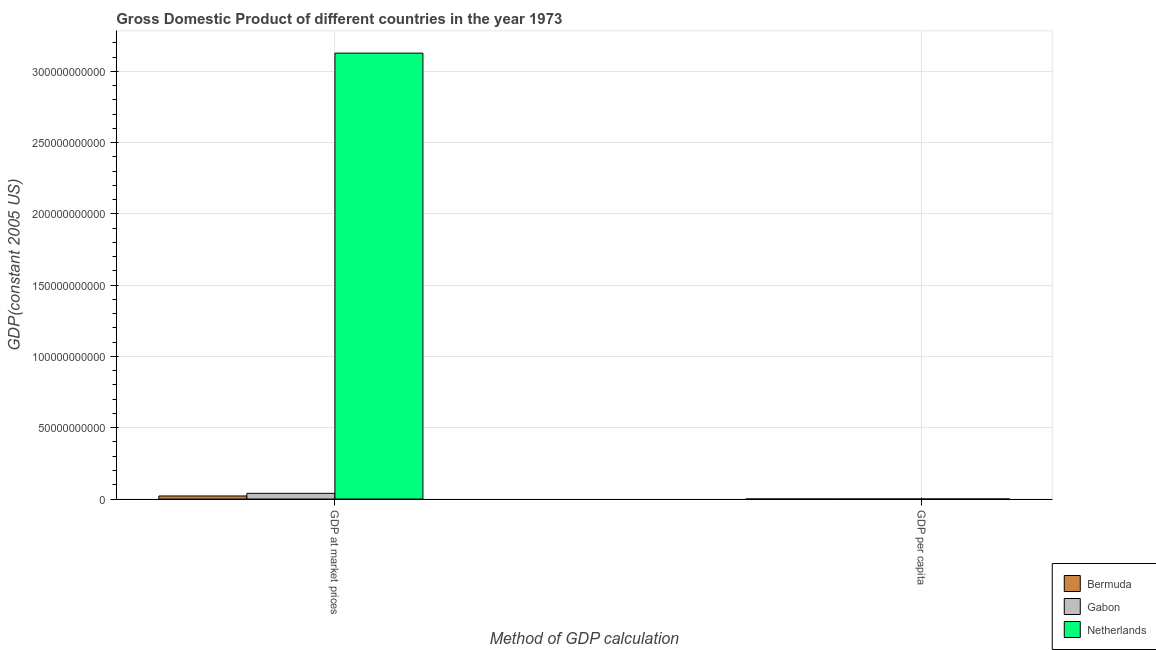How many different coloured bars are there?
Give a very brief answer. 3. Are the number of bars per tick equal to the number of legend labels?
Offer a very short reply. Yes. Are the number of bars on each tick of the X-axis equal?
Make the answer very short. Yes. How many bars are there on the 1st tick from the left?
Provide a short and direct response. 3. How many bars are there on the 1st tick from the right?
Offer a terse response. 3. What is the label of the 1st group of bars from the left?
Give a very brief answer. GDP at market prices. What is the gdp at market prices in Netherlands?
Give a very brief answer. 3.13e+11. Across all countries, what is the maximum gdp per capita?
Offer a terse response. 3.98e+04. Across all countries, what is the minimum gdp at market prices?
Keep it short and to the point. 2.14e+09. In which country was the gdp per capita minimum?
Ensure brevity in your answer.  Gabon. What is the total gdp at market prices in the graph?
Provide a succinct answer. 3.19e+11. What is the difference between the gdp at market prices in Bermuda and that in Gabon?
Offer a terse response. -1.85e+09. What is the difference between the gdp at market prices in Bermuda and the gdp per capita in Netherlands?
Keep it short and to the point. 2.14e+09. What is the average gdp per capita per country?
Give a very brief answer. 2.32e+04. What is the difference between the gdp per capita and gdp at market prices in Netherlands?
Your response must be concise. -3.13e+11. What is the ratio of the gdp at market prices in Bermuda to that in Netherlands?
Your answer should be compact. 0.01. In how many countries, is the gdp per capita greater than the average gdp per capita taken over all countries?
Offer a terse response. 2. What does the 1st bar from the left in GDP per capita represents?
Provide a succinct answer. Bermuda. What does the 2nd bar from the right in GDP per capita represents?
Your response must be concise. Gabon. How many bars are there?
Ensure brevity in your answer.  6. Are all the bars in the graph horizontal?
Your answer should be compact. No. Does the graph contain any zero values?
Keep it short and to the point. No. How are the legend labels stacked?
Provide a succinct answer. Vertical. What is the title of the graph?
Your answer should be very brief. Gross Domestic Product of different countries in the year 1973. What is the label or title of the X-axis?
Provide a succinct answer. Method of GDP calculation. What is the label or title of the Y-axis?
Provide a succinct answer. GDP(constant 2005 US). What is the GDP(constant 2005 US) in Bermuda in GDP at market prices?
Offer a very short reply. 2.14e+09. What is the GDP(constant 2005 US) in Gabon in GDP at market prices?
Offer a very short reply. 3.99e+09. What is the GDP(constant 2005 US) in Netherlands in GDP at market prices?
Your answer should be compact. 3.13e+11. What is the GDP(constant 2005 US) in Bermuda in GDP per capita?
Provide a short and direct response. 3.98e+04. What is the GDP(constant 2005 US) of Gabon in GDP per capita?
Offer a very short reply. 6388.75. What is the GDP(constant 2005 US) in Netherlands in GDP per capita?
Provide a short and direct response. 2.33e+04. Across all Method of GDP calculation, what is the maximum GDP(constant 2005 US) of Bermuda?
Provide a short and direct response. 2.14e+09. Across all Method of GDP calculation, what is the maximum GDP(constant 2005 US) in Gabon?
Offer a terse response. 3.99e+09. Across all Method of GDP calculation, what is the maximum GDP(constant 2005 US) in Netherlands?
Your answer should be compact. 3.13e+11. Across all Method of GDP calculation, what is the minimum GDP(constant 2005 US) of Bermuda?
Give a very brief answer. 3.98e+04. Across all Method of GDP calculation, what is the minimum GDP(constant 2005 US) in Gabon?
Make the answer very short. 6388.75. Across all Method of GDP calculation, what is the minimum GDP(constant 2005 US) in Netherlands?
Provide a short and direct response. 2.33e+04. What is the total GDP(constant 2005 US) of Bermuda in the graph?
Provide a succinct answer. 2.14e+09. What is the total GDP(constant 2005 US) of Gabon in the graph?
Offer a very short reply. 3.99e+09. What is the total GDP(constant 2005 US) in Netherlands in the graph?
Provide a short and direct response. 3.13e+11. What is the difference between the GDP(constant 2005 US) of Bermuda in GDP at market prices and that in GDP per capita?
Keep it short and to the point. 2.14e+09. What is the difference between the GDP(constant 2005 US) in Gabon in GDP at market prices and that in GDP per capita?
Ensure brevity in your answer.  3.99e+09. What is the difference between the GDP(constant 2005 US) of Netherlands in GDP at market prices and that in GDP per capita?
Provide a short and direct response. 3.13e+11. What is the difference between the GDP(constant 2005 US) of Bermuda in GDP at market prices and the GDP(constant 2005 US) of Gabon in GDP per capita?
Make the answer very short. 2.14e+09. What is the difference between the GDP(constant 2005 US) of Bermuda in GDP at market prices and the GDP(constant 2005 US) of Netherlands in GDP per capita?
Your answer should be compact. 2.14e+09. What is the difference between the GDP(constant 2005 US) of Gabon in GDP at market prices and the GDP(constant 2005 US) of Netherlands in GDP per capita?
Ensure brevity in your answer.  3.99e+09. What is the average GDP(constant 2005 US) in Bermuda per Method of GDP calculation?
Make the answer very short. 1.07e+09. What is the average GDP(constant 2005 US) of Gabon per Method of GDP calculation?
Offer a terse response. 2.00e+09. What is the average GDP(constant 2005 US) of Netherlands per Method of GDP calculation?
Provide a succinct answer. 1.56e+11. What is the difference between the GDP(constant 2005 US) in Bermuda and GDP(constant 2005 US) in Gabon in GDP at market prices?
Offer a very short reply. -1.85e+09. What is the difference between the GDP(constant 2005 US) in Bermuda and GDP(constant 2005 US) in Netherlands in GDP at market prices?
Give a very brief answer. -3.11e+11. What is the difference between the GDP(constant 2005 US) in Gabon and GDP(constant 2005 US) in Netherlands in GDP at market prices?
Give a very brief answer. -3.09e+11. What is the difference between the GDP(constant 2005 US) of Bermuda and GDP(constant 2005 US) of Gabon in GDP per capita?
Give a very brief answer. 3.34e+04. What is the difference between the GDP(constant 2005 US) of Bermuda and GDP(constant 2005 US) of Netherlands in GDP per capita?
Give a very brief answer. 1.65e+04. What is the difference between the GDP(constant 2005 US) in Gabon and GDP(constant 2005 US) in Netherlands in GDP per capita?
Make the answer very short. -1.69e+04. What is the ratio of the GDP(constant 2005 US) of Bermuda in GDP at market prices to that in GDP per capita?
Your answer should be very brief. 5.38e+04. What is the ratio of the GDP(constant 2005 US) of Gabon in GDP at market prices to that in GDP per capita?
Provide a short and direct response. 6.25e+05. What is the ratio of the GDP(constant 2005 US) of Netherlands in GDP at market prices to that in GDP per capita?
Offer a very short reply. 1.34e+07. What is the difference between the highest and the second highest GDP(constant 2005 US) of Bermuda?
Make the answer very short. 2.14e+09. What is the difference between the highest and the second highest GDP(constant 2005 US) of Gabon?
Offer a very short reply. 3.99e+09. What is the difference between the highest and the second highest GDP(constant 2005 US) in Netherlands?
Provide a succinct answer. 3.13e+11. What is the difference between the highest and the lowest GDP(constant 2005 US) in Bermuda?
Offer a terse response. 2.14e+09. What is the difference between the highest and the lowest GDP(constant 2005 US) in Gabon?
Provide a succinct answer. 3.99e+09. What is the difference between the highest and the lowest GDP(constant 2005 US) of Netherlands?
Your response must be concise. 3.13e+11. 